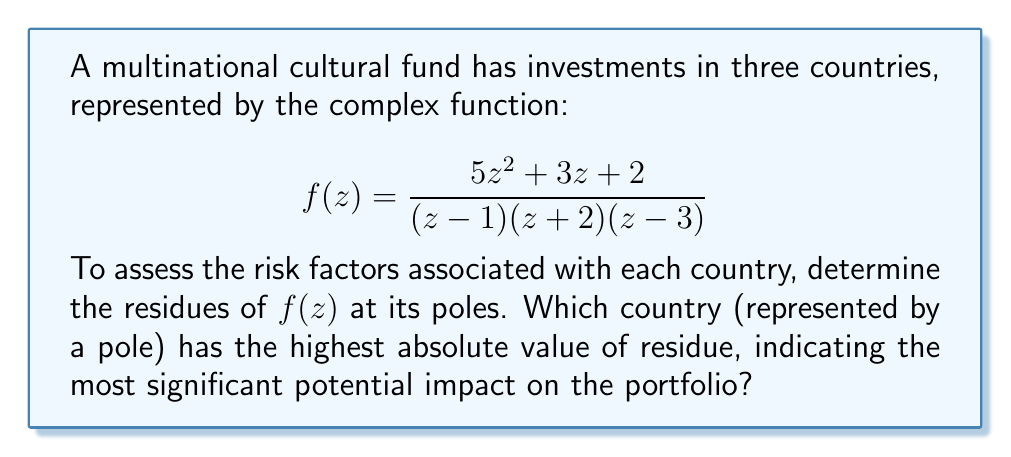Show me your answer to this math problem. To solve this problem, we need to follow these steps:

1) Identify the poles of the function:
   The poles are at $z=1$, $z=-2$, and $z=3$.

2) Calculate the residues at each pole using the formula for simple poles:
   $$\text{Res}(f,a) = \lim_{z \to a} (z-a)f(z)$$

3) For $z=1$:
   $$\text{Res}(f,1) = \lim_{z \to 1} (z-1)\frac{5z^2 + 3z + 2}{(z-1)(z+2)(z-3)}$$
   $$= \lim_{z \to 1} \frac{5z^2 + 3z + 2}{(z+2)(z-3)} = \frac{5(1)^2 + 3(1) + 2}{(1+2)(1-3)} = -\frac{10}{6} = -\frac{5}{3}$$

4) For $z=-2$:
   $$\text{Res}(f,-2) = \lim_{z \to -2} (z+2)\frac{5z^2 + 3z + 2}{(z-1)(z+2)(z-3)}$$
   $$= \lim_{z \to -2} \frac{5z^2 + 3z + 2}{(z-1)(z-3)} = \frac{5(-2)^2 + 3(-2) + 2}{(-2-1)(-2-3)} = \frac{14}{15}$$

5) For $z=3$:
   $$\text{Res}(f,3) = \lim_{z \to 3} (z-3)\frac{5z^2 + 3z + 2}{(z-1)(z+2)(z-3)}$$
   $$= \lim_{z \to 3} \frac{5z^2 + 3z + 2}{(z-1)(z+2)} = \frac{5(3)^2 + 3(3) + 2}{(3-1)(3+2)} = \frac{56}{20} = \frac{14}{5}$$

6) Compare the absolute values of the residues:
   $|-\frac{5}{3}| = 1.67$
   $|\frac{14}{15}| = 0.93$
   $|\frac{14}{5}| = 2.8$

The highest absolute value is $2.8$, corresponding to the pole at $z=3$.
Answer: The country represented by $z=3$ has the highest absolute residue value of $2.8$, indicating the most significant potential impact on the portfolio. 